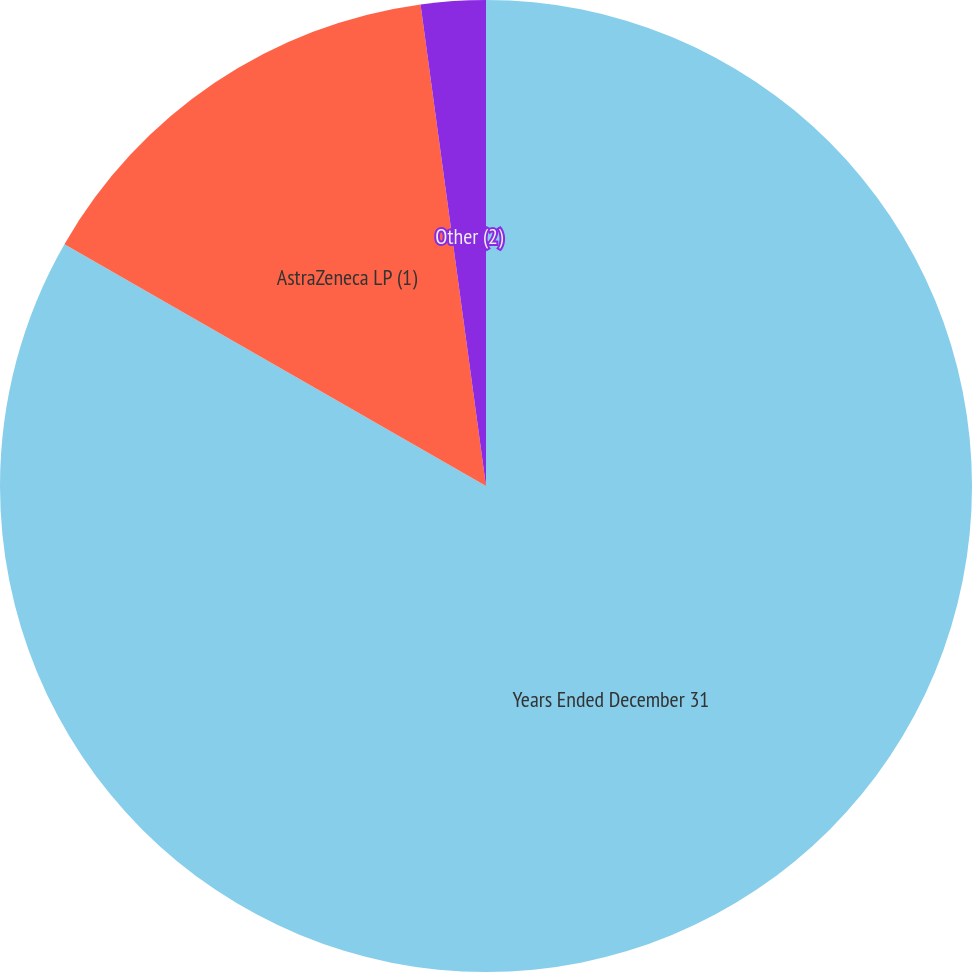<chart> <loc_0><loc_0><loc_500><loc_500><pie_chart><fcel>Years Ended December 31<fcel>AstraZeneca LP (1)<fcel>Other (2)<nl><fcel>83.29%<fcel>14.56%<fcel>2.15%<nl></chart> 